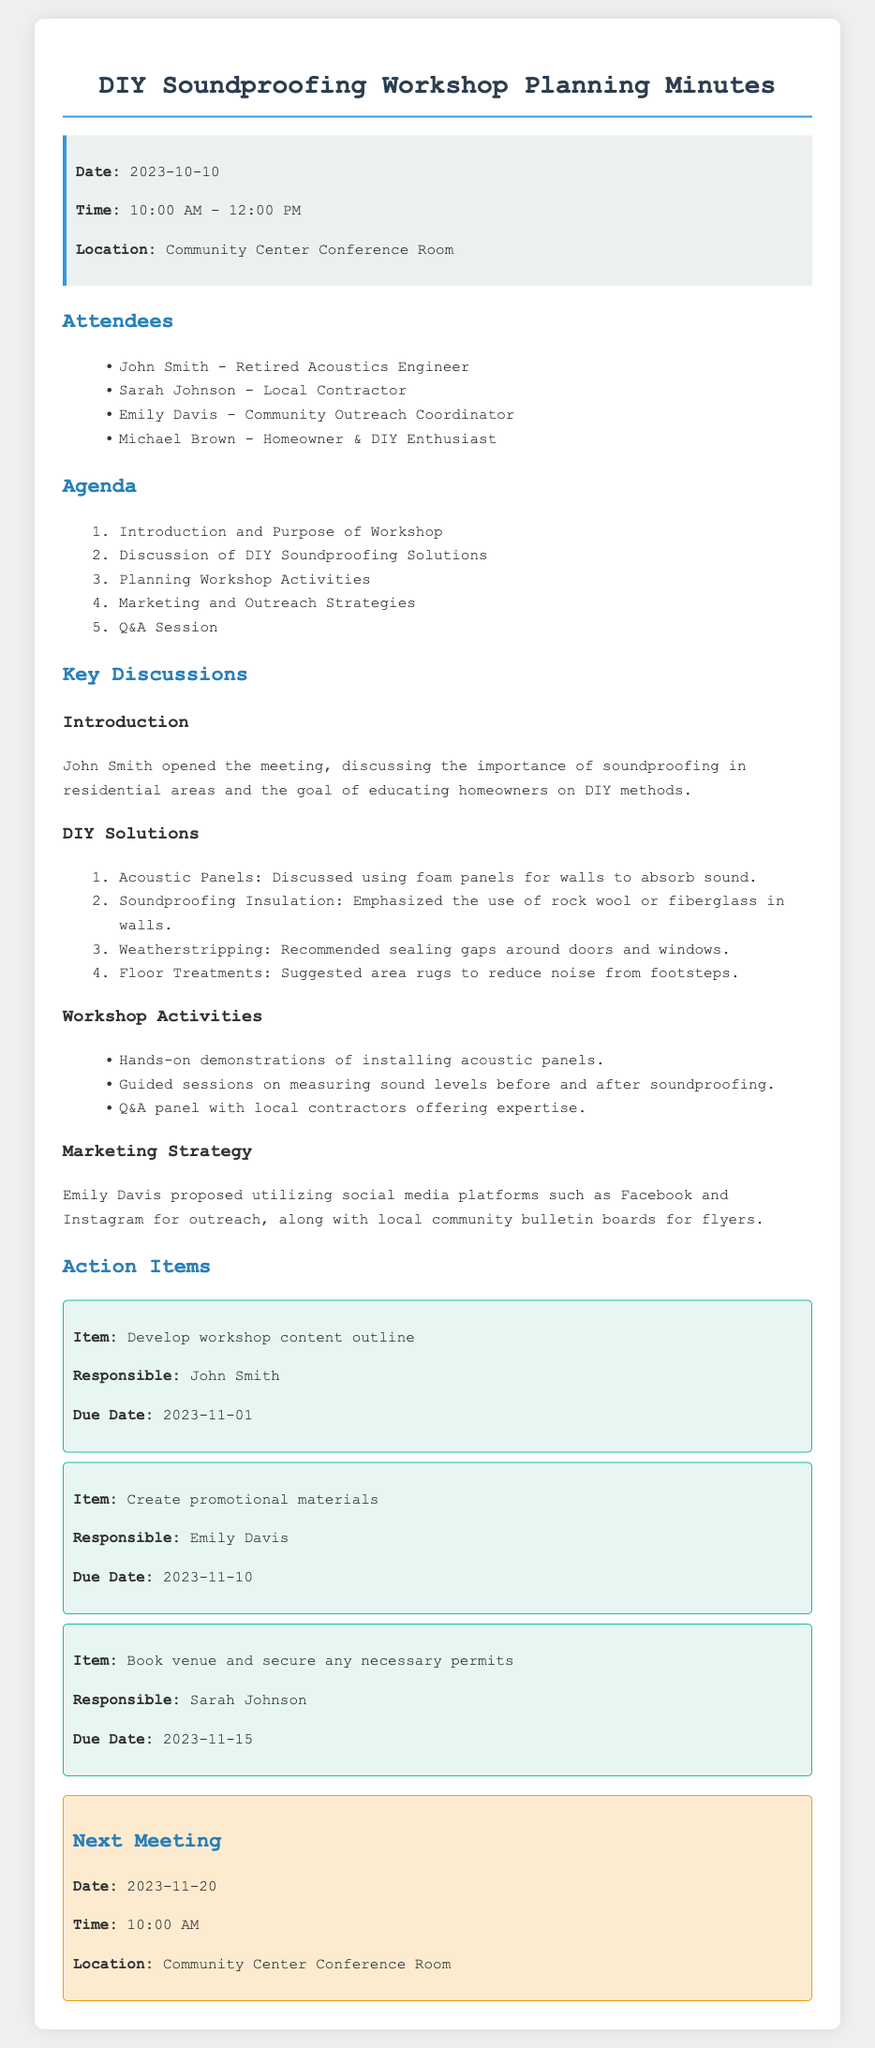what is the date of the meeting? The date of the meeting is stated in the document header.
Answer: 2023-10-10 who is the local contractor attending the meeting? The document lists the attendees, including their roles.
Answer: Sarah Johnson what is one of the DIY soundproofing solutions discussed? The document outlines specific solutions discussed in the meeting.
Answer: Acoustic Panels what activities will the workshop include? The document specifies the activities planned for the workshop.
Answer: Hands-on demonstrations of installing acoustic panels when is the next meeting scheduled? The next meeting date is mentioned in a dedicated section at the end of the document.
Answer: 2023-11-20 who is responsible for creating promotional materials? Action items include responsibilities assigned to specific individuals.
Answer: Emily Davis what type of outreach strategy was proposed? The document discusses marketing strategies suggested for the workshop.
Answer: Social media platforms how long is the workshop scheduled to last? The duration of the meeting is noted in the header.
Answer: 2 hours 